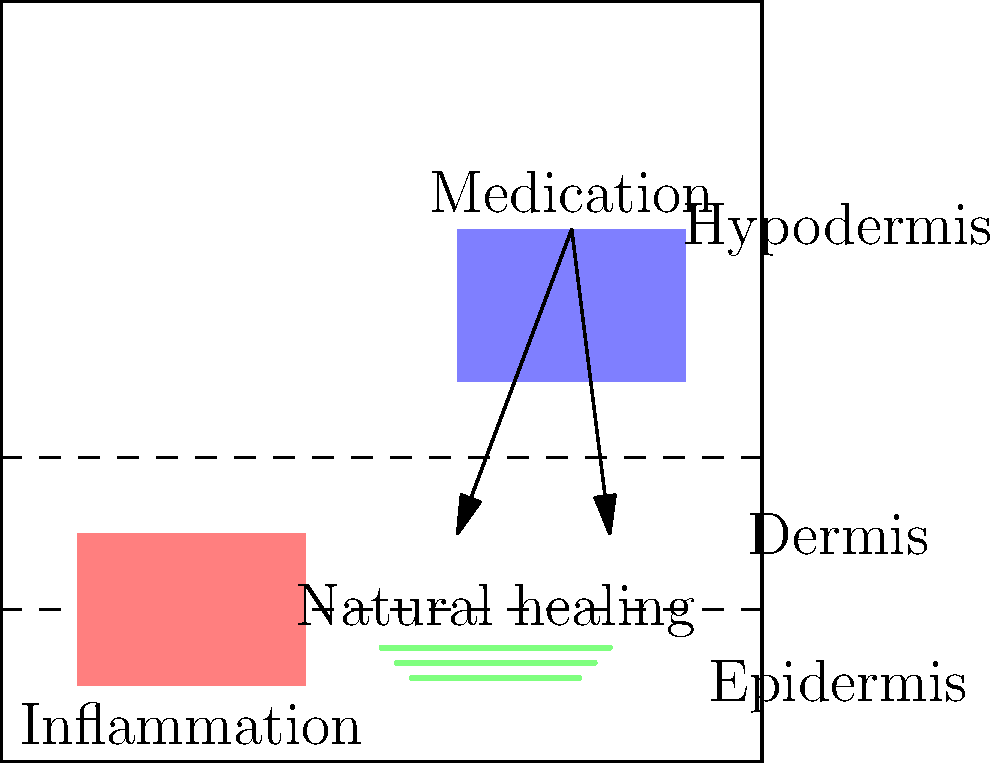Analyze the illustration comparing the body's natural healing process to medical interventions. How might the interaction between inflammation, natural healing, and medication influence the overall recovery process? Discuss potential advantages and disadvantages of relying solely on the body's self-healing mechanisms versus incorporating medical interventions. 1. Inflammation: The illustration shows an area of inflammation in the epidermis and dermis layers of the skin. This is the body's initial response to injury or infection.

2. Natural healing: Represented by green lines in the dermis, this shows the body's attempt to repair damaged tissue without external intervention.

3. Medication: Depicted as a blue area in the hypodermis, this represents medical intervention introduced to assist the healing process.

4. Interaction:
   a) Inflammation triggers the natural healing process by attracting immune cells and increasing blood flow to the affected area.
   b) Natural healing mechanisms work to repair tissue damage and fight off pathogens.
   c) Medication can target specific aspects of the healing process, such as reducing inflammation or boosting the immune response.

5. Advantages of self-healing:
   a) Avoids potential side effects of medications
   b) Strengthens the body's natural defense mechanisms over time
   c) Cost-effective

6. Disadvantages of relying solely on self-healing:
   a) May be slower than with medical intervention
   b) Some conditions may be too severe for the body to handle alone
   c) Chronic inflammation can lead to further tissue damage

7. Advantages of medical interventions:
   a) Can accelerate the healing process
   b) Necessary for managing severe conditions
   c) Can provide pain relief and improve quality of life during recovery

8. Disadvantages of medical interventions:
   a) Potential side effects from medications
   b) Risk of developing drug resistance
   c) May weaken the body's natural healing responses over time if overused

The optimal approach often involves a balance between allowing the body's natural healing processes to work and using targeted medical interventions when necessary to support and enhance recovery.
Answer: Balanced approach: Leverage natural healing with targeted medical interventions as needed for optimal recovery. 